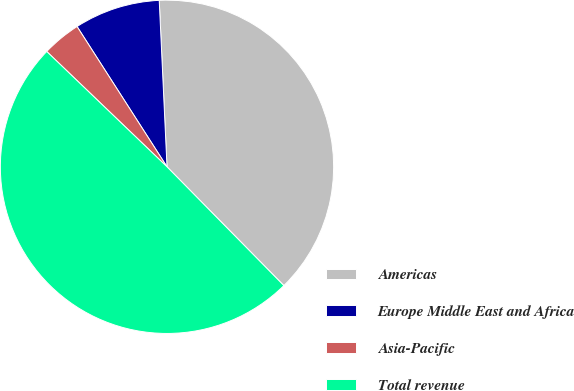<chart> <loc_0><loc_0><loc_500><loc_500><pie_chart><fcel>Americas<fcel>Europe Middle East and Africa<fcel>Asia-Pacific<fcel>Total revenue<nl><fcel>38.37%<fcel>8.33%<fcel>3.76%<fcel>49.53%<nl></chart> 